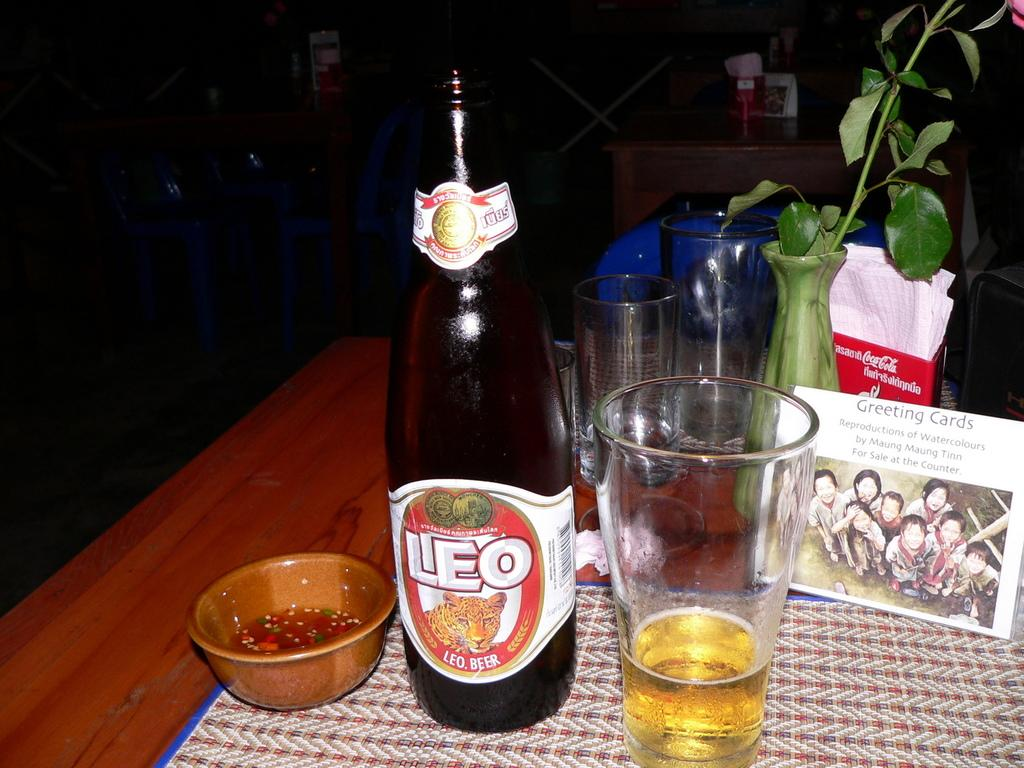Provide a one-sentence caption for the provided image. A bottle of Leo beer, a glass of beer and a bowl with something red in it. 